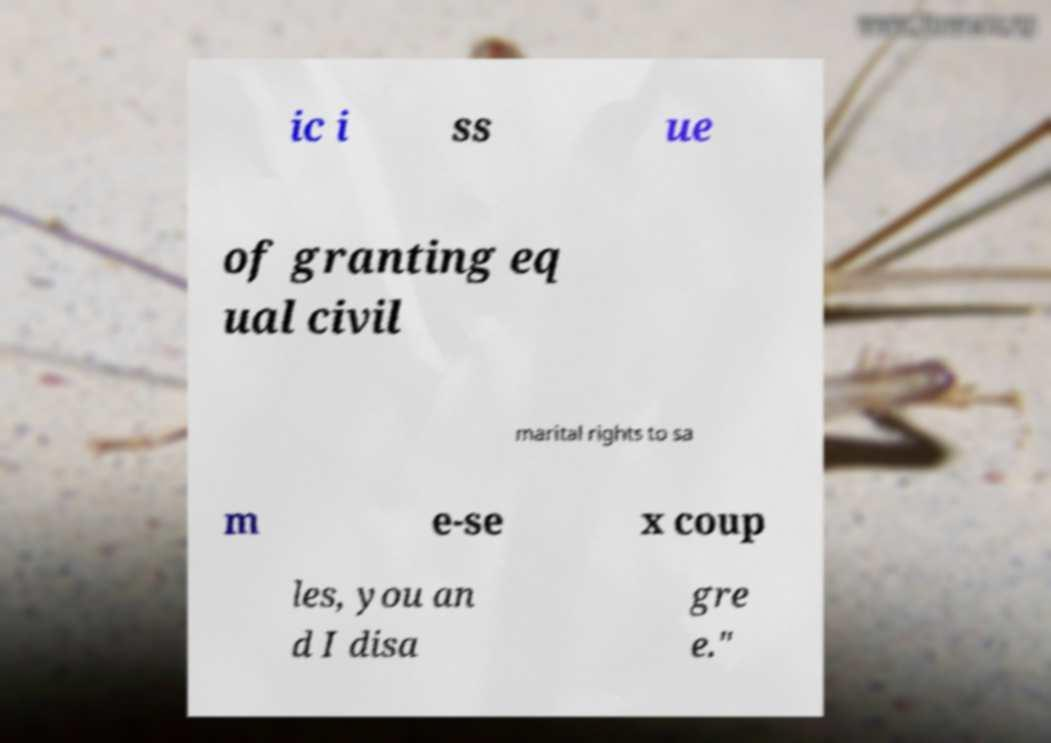I need the written content from this picture converted into text. Can you do that? ic i ss ue of granting eq ual civil marital rights to sa m e-se x coup les, you an d I disa gre e." 